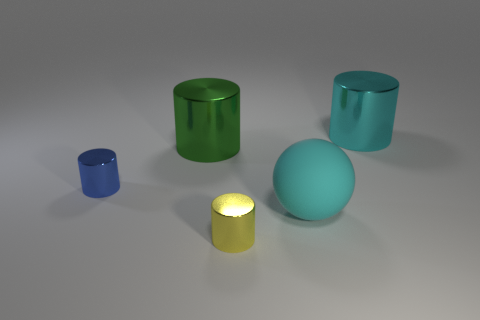There is another big object that is the same color as the rubber thing; what material is it?
Offer a terse response. Metal. What size is the metallic cylinder that is the same color as the rubber ball?
Offer a very short reply. Large. Are there any small cyan matte cubes?
Ensure brevity in your answer.  No. What is the shape of the other big thing that is made of the same material as the green object?
Make the answer very short. Cylinder. Is the shape of the big rubber thing the same as the large object that is to the left of the yellow metal object?
Give a very brief answer. No. What material is the large cylinder on the left side of the cylinder that is behind the big green metallic cylinder made of?
Provide a succinct answer. Metal. What number of other things are there of the same shape as the yellow shiny thing?
Offer a very short reply. 3. There is a big shiny thing behind the green object; is it the same shape as the small blue metallic object left of the yellow shiny object?
Provide a succinct answer. Yes. Is there anything else that is the same material as the green thing?
Provide a succinct answer. Yes. What material is the cyan sphere?
Your answer should be very brief. Rubber. 